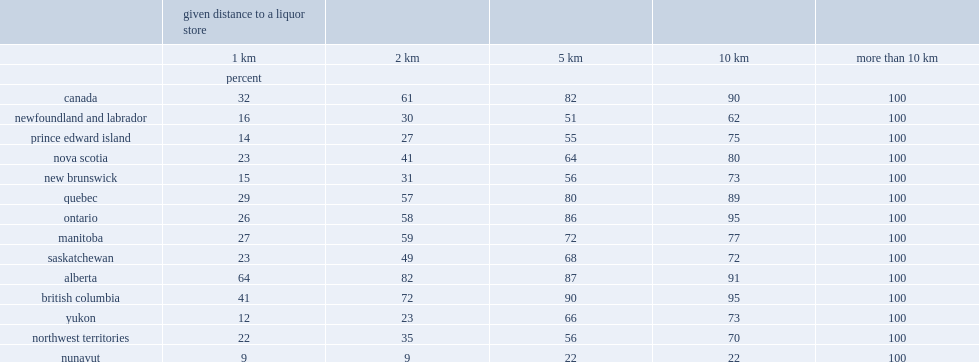What is the percentage of canadians all across the country live within 10 kilometres or less distance from a liquor store? 90.0. What is the percentage of canadians all across the country live within five kilometres or less distance from a liquor store? 82.0. What is the percentage of nunavut residents living within 10 kilometres of a liquor store? 22.0. Which are the top four provinces where liquor stores are most accessible within 10 kilometres? Ontario british columbia alberta quebec. What is the percentage of having access to a liquor store within 10 kilometres in newfoundland and labrador? 62.0. 